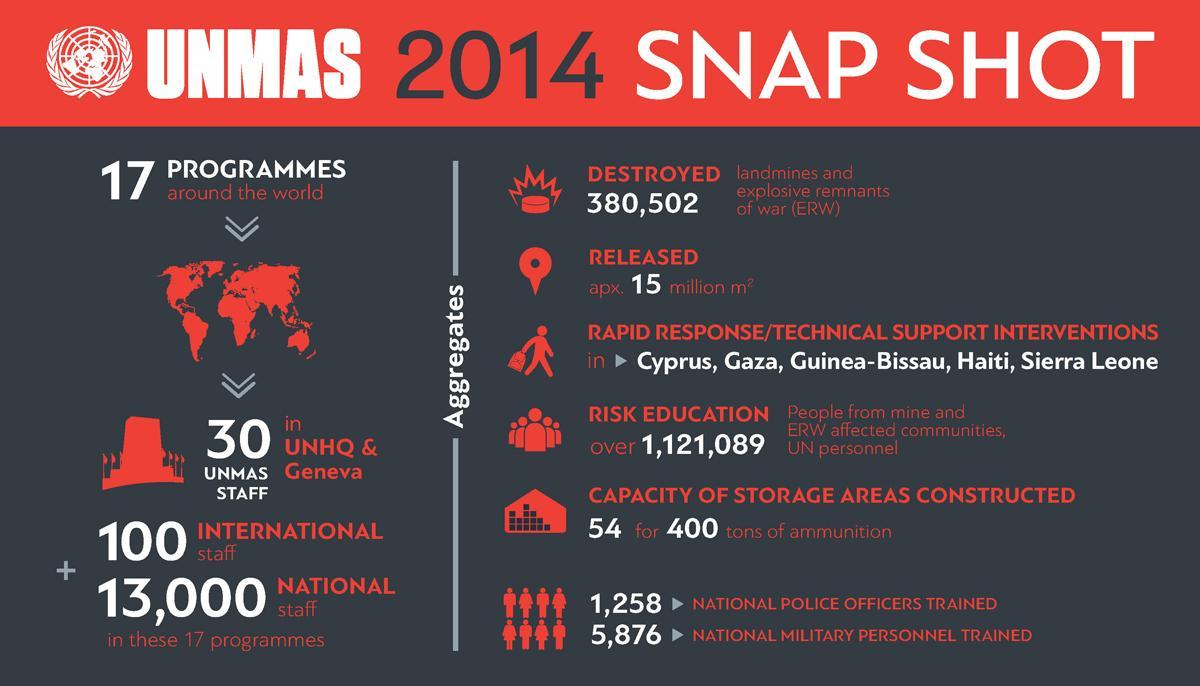What is the capacity of storage areas constructed by UNMAS 2014?
Answer the question with a short phrase. 54 for 400 tons of ammunition How many national military personnels were trained in UNMAS 2014? 5,876 How many landmines & explosive remnants of war were destroyed by UNMAS 2014? 380,502 How many national police officers were trained in UNMAS 2014? 1,258 